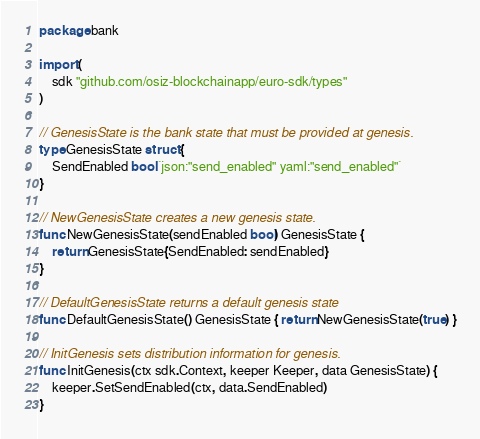<code> <loc_0><loc_0><loc_500><loc_500><_Go_>package bank

import (
	sdk "github.com/osiz-blockchainapp/euro-sdk/types"
)

// GenesisState is the bank state that must be provided at genesis.
type GenesisState struct {
	SendEnabled bool `json:"send_enabled" yaml:"send_enabled"`
}

// NewGenesisState creates a new genesis state.
func NewGenesisState(sendEnabled bool) GenesisState {
	return GenesisState{SendEnabled: sendEnabled}
}

// DefaultGenesisState returns a default genesis state
func DefaultGenesisState() GenesisState { return NewGenesisState(true) }

// InitGenesis sets distribution information for genesis.
func InitGenesis(ctx sdk.Context, keeper Keeper, data GenesisState) {
	keeper.SetSendEnabled(ctx, data.SendEnabled)
}
</code> 